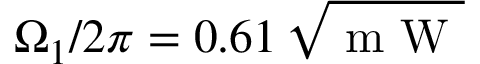Convert formula to latex. <formula><loc_0><loc_0><loc_500><loc_500>\Omega _ { 1 } / 2 \pi = 0 . 6 1 \, \sqrt { m W }</formula> 